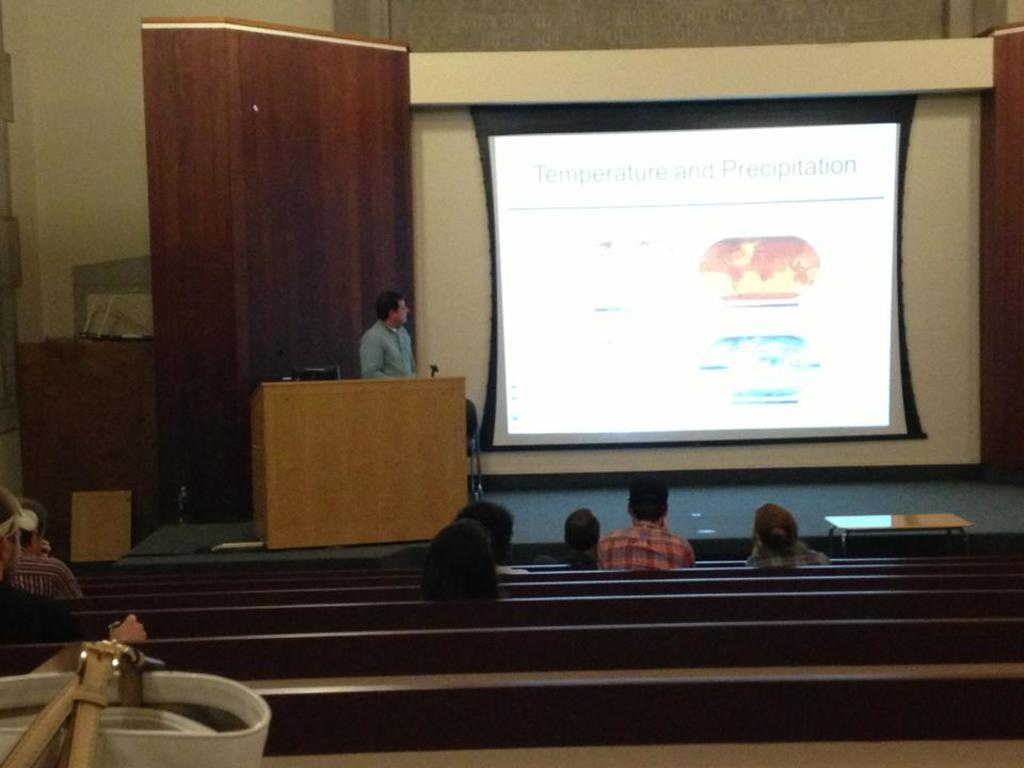What are the people in the image doing? There are persons sitting in the image, which suggests they might be resting or engaged in a conversation. What object is visible near the persons? There is a bag visible in the image, which could belong to one of the persons. What type of furniture is present in the image? There are benches and a table in the image. What is the man standing in the image doing? It is not clear what the man standing in the image is doing, but he might be observing the scene or waiting for someone. What device is on the table in the image? There is a laptop on the table in the image, which could be used for work or leisure. What is visible on the screen in the image? There is a screen visible in the image, but without more context, it is impossible to determine what is being displayed. What architectural feature is present in the image? There is a wall in the image, which could be part of a building or structure. What type of popcorn is being served to the goat in the image? There is no goat or popcorn present in the image. What type of waste is visible in the image? There is no waste visible in the image. 